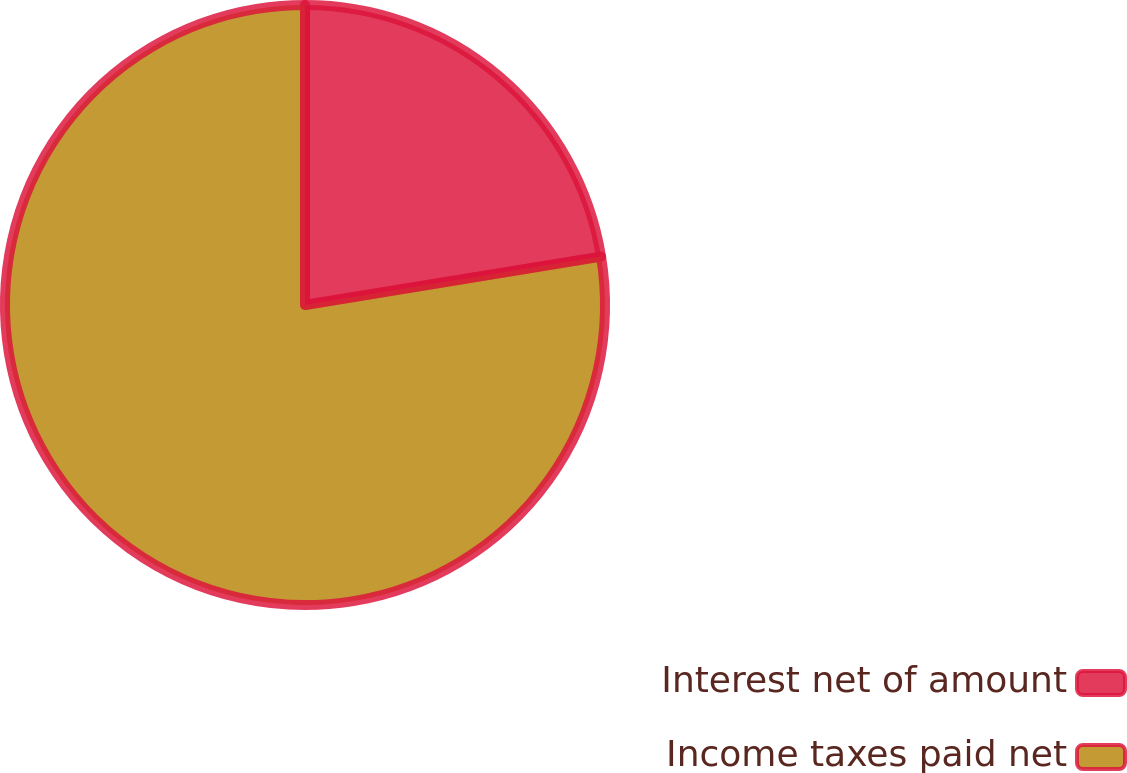Convert chart. <chart><loc_0><loc_0><loc_500><loc_500><pie_chart><fcel>Interest net of amount<fcel>Income taxes paid net<nl><fcel>22.42%<fcel>77.58%<nl></chart> 